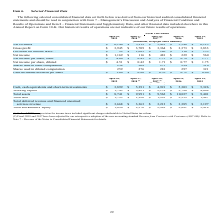According to Netapp's financial document, What was the working capital in 2019? According to the financial document, 1,743 (in millions). The relevant text states: "Working capital $ 1,743 $ 3,421 $ 2,178 $ 2,786 $ 4,064..." Also, What years does the table provide information for total assets? The document contains multiple relevant values: 2019, 2018, 2017, 2016, 2015. From the document: "April 27, 2018 (2) 2019 2016 2015 April 28, 2017 (2)..." Also, What was the total debt in 2015? According to the financial document, 1,487 (in millions). The relevant text states: "Total debt $ 1,793 $ 1,926 $ 1,993 $ 2,339 $ 1,487..." Also, can you calculate: What was the change in working capital between 2015 and 2016? Based on the calculation: 2,786-4,064, the result is -1278 (in millions). This is based on the information: "Working capital $ 1,743 $ 3,421 $ 2,178 $ 2,786 $ 4,064 Working capital $ 1,743 $ 3,421 $ 2,178 $ 2,786 $ 4,064..." The key data points involved are: 2,786, 4,064. Also, How many years did total assets exceed $10,000 million? Based on the analysis, there are 1 instances. The counting process: 2016. Also, can you calculate: What was the percentage change in Total stockholders' equity between 2018 and 2019? To answer this question, I need to perform calculations using the financial data. The calculation is: (1,090-2,276)/2,276, which equals -52.11 (percentage). This is based on the information: "Total stockholders' equity $ 1,090 $ 2,276 $ 2,949 $ 2,881 $ 3,414 Total stockholders' equity $ 1,090 $ 2,276 $ 2,949 $ 2,881 $ 3,414..." The key data points involved are: 1,090, 2,276. 